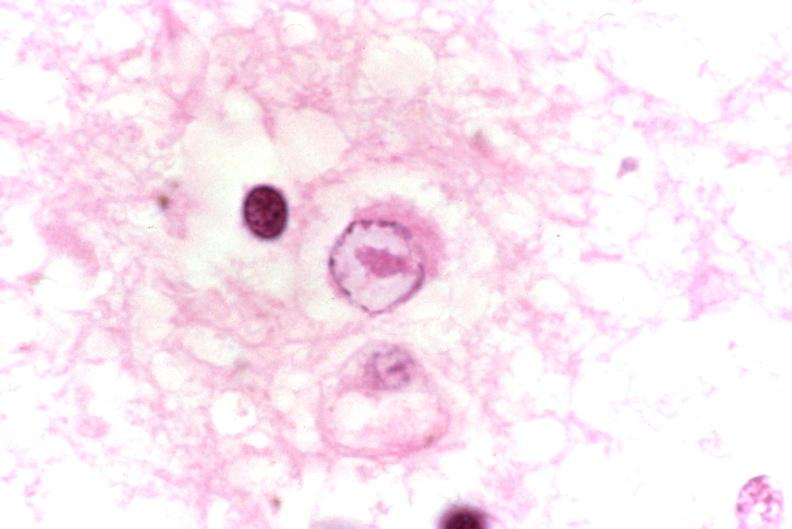does atrophy show brain, herpes encephalitis, intranuclear inclusion body?
Answer the question using a single word or phrase. No 